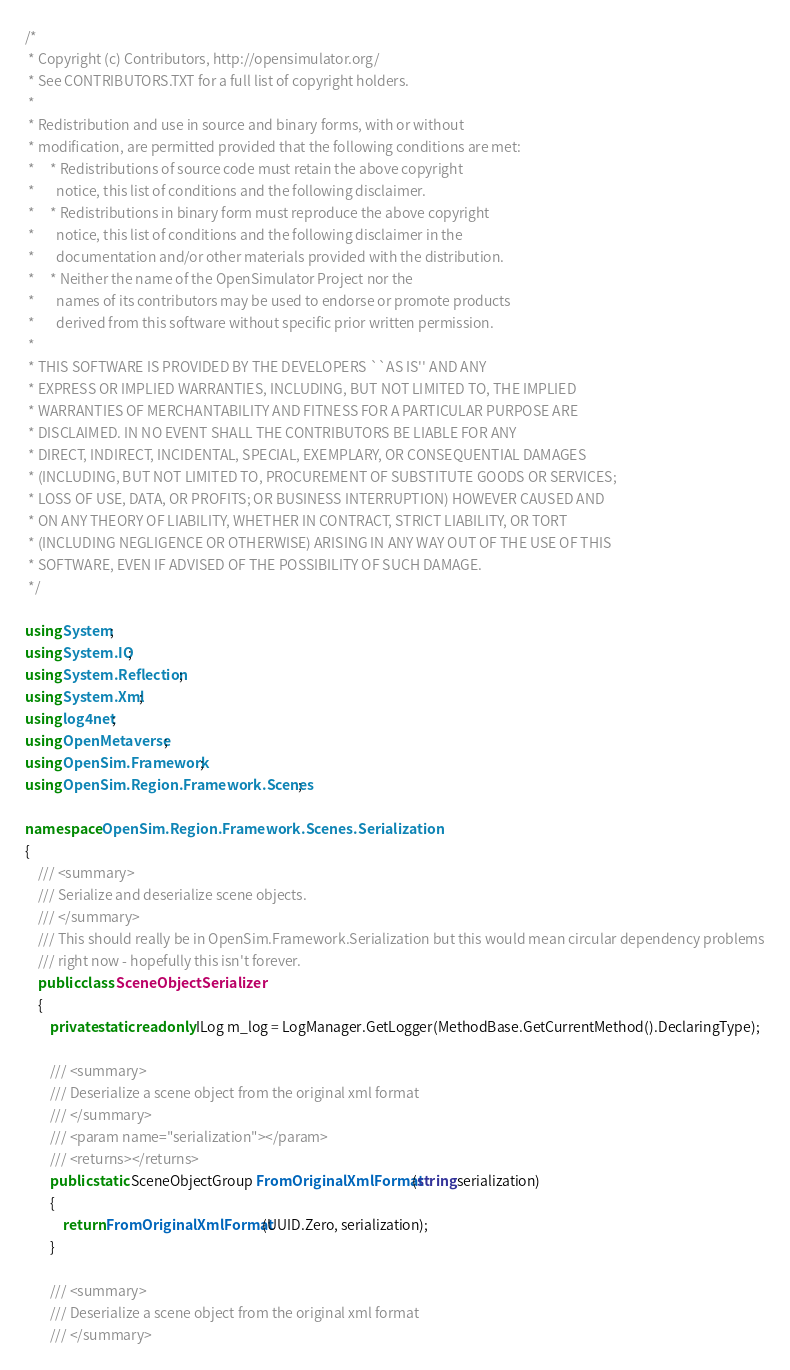Convert code to text. <code><loc_0><loc_0><loc_500><loc_500><_C#_>/*
 * Copyright (c) Contributors, http://opensimulator.org/
 * See CONTRIBUTORS.TXT for a full list of copyright holders.
 *
 * Redistribution and use in source and binary forms, with or without
 * modification, are permitted provided that the following conditions are met:
 *     * Redistributions of source code must retain the above copyright
 *       notice, this list of conditions and the following disclaimer.
 *     * Redistributions in binary form must reproduce the above copyright
 *       notice, this list of conditions and the following disclaimer in the
 *       documentation and/or other materials provided with the distribution.
 *     * Neither the name of the OpenSimulator Project nor the
 *       names of its contributors may be used to endorse or promote products
 *       derived from this software without specific prior written permission.
 *
 * THIS SOFTWARE IS PROVIDED BY THE DEVELOPERS ``AS IS'' AND ANY
 * EXPRESS OR IMPLIED WARRANTIES, INCLUDING, BUT NOT LIMITED TO, THE IMPLIED
 * WARRANTIES OF MERCHANTABILITY AND FITNESS FOR A PARTICULAR PURPOSE ARE
 * DISCLAIMED. IN NO EVENT SHALL THE CONTRIBUTORS BE LIABLE FOR ANY
 * DIRECT, INDIRECT, INCIDENTAL, SPECIAL, EXEMPLARY, OR CONSEQUENTIAL DAMAGES
 * (INCLUDING, BUT NOT LIMITED TO, PROCUREMENT OF SUBSTITUTE GOODS OR SERVICES;
 * LOSS OF USE, DATA, OR PROFITS; OR BUSINESS INTERRUPTION) HOWEVER CAUSED AND
 * ON ANY THEORY OF LIABILITY, WHETHER IN CONTRACT, STRICT LIABILITY, OR TORT
 * (INCLUDING NEGLIGENCE OR OTHERWISE) ARISING IN ANY WAY OUT OF THE USE OF THIS
 * SOFTWARE, EVEN IF ADVISED OF THE POSSIBILITY OF SUCH DAMAGE.
 */

using System;
using System.IO;
using System.Reflection;
using System.Xml;
using log4net;
using OpenMetaverse;
using OpenSim.Framework;
using OpenSim.Region.Framework.Scenes;

namespace OpenSim.Region.Framework.Scenes.Serialization
{
    /// <summary>
    /// Serialize and deserialize scene objects.
    /// </summary>
    /// This should really be in OpenSim.Framework.Serialization but this would mean circular dependency problems
    /// right now - hopefully this isn't forever.
    public class SceneObjectSerializer
    {
        private static readonly ILog m_log = LogManager.GetLogger(MethodBase.GetCurrentMethod().DeclaringType);
        
        /// <summary>
        /// Deserialize a scene object from the original xml format
        /// </summary>
        /// <param name="serialization"></param>
        /// <returns></returns>
        public static SceneObjectGroup FromOriginalXmlFormat(string serialization)
        {
            return FromOriginalXmlFormat(UUID.Zero, serialization);
        }
        
        /// <summary>
        /// Deserialize a scene object from the original xml format
        /// </summary></code> 